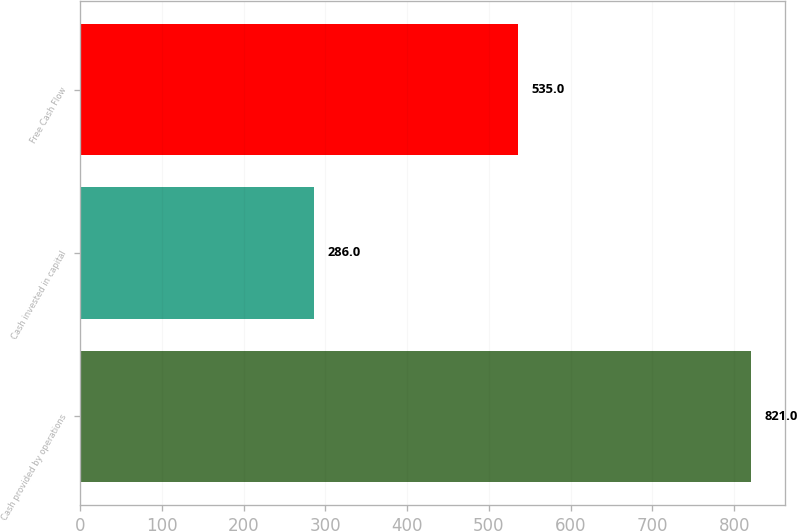<chart> <loc_0><loc_0><loc_500><loc_500><bar_chart><fcel>Cash provided by operations<fcel>Cash invested in capital<fcel>Free Cash Flow<nl><fcel>821<fcel>286<fcel>535<nl></chart> 